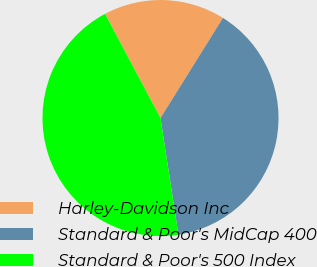Convert chart to OTSL. <chart><loc_0><loc_0><loc_500><loc_500><pie_chart><fcel>Harley-Davidson Inc<fcel>Standard & Poor's MidCap 400<fcel>Standard & Poor's 500 Index<nl><fcel>16.67%<fcel>38.69%<fcel>44.64%<nl></chart> 